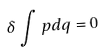<formula> <loc_0><loc_0><loc_500><loc_500>\delta \int p d q = 0</formula> 